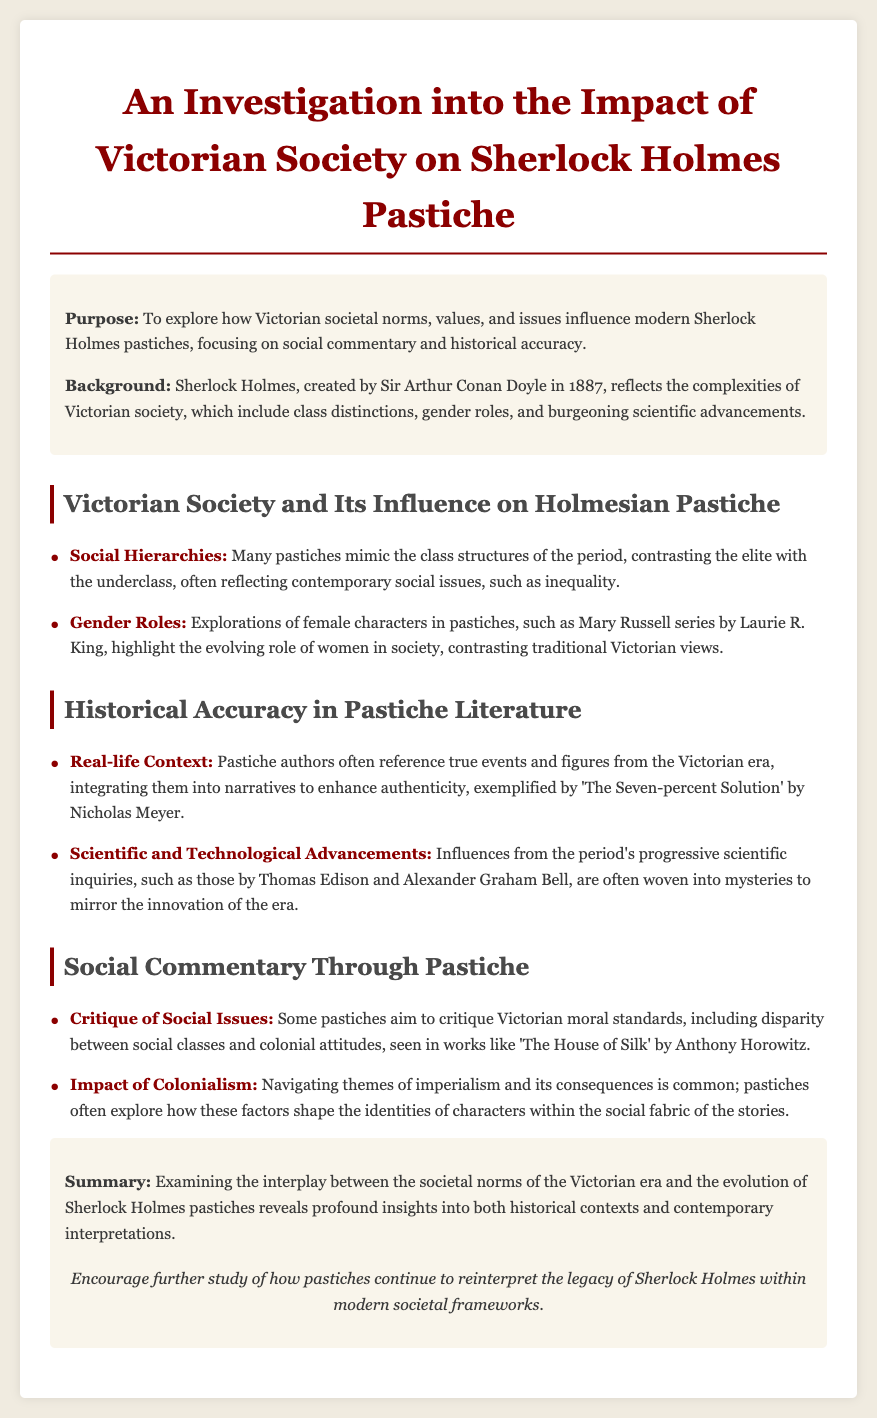What is the purpose of the investigation? The purpose is outlined in the introduction section, focusing on the exploration of Victorian societal norms and their influence on modern pastiches.
Answer: To explore how Victorian societal norms, values, and issues influence modern Sherlock Holmes pastiches What year was Sherlock Holmes created? The background section provides the information on the year of creation, which is noted as 1887.
Answer: 1887 Name one series that highlights evolving female roles. The document mentions the Mary Russell series by Laurie R. King as an example.
Answer: Mary Russell series Which author wrote 'The Seven-percent Solution'? The key point about real-life context identifies Nicholas Meyer as the author of this pastiche.
Answer: Nicholas Meyer What social issue do some pastiches critique? The document indicates that pastiches critique disparity between social classes as one of the Victorian moral standards.
Answer: Disparity between social classes How do pastiches enhance authenticity in their narratives? The key point about real-life context explains that pastiche authors integrate true events and figures to achieve this.
Answer: Integrating true events and figures What theme do pastiches often explore regarding colonialism? The document states that pastiches navigate themes of imperialism and its consequences within character identities.
Answer: Imperialism and its consequences Which author created 'The House of Silk'? The critique of social issues specifies that this work is by Anthony Horowitz.
Answer: Anthony Horowitz What does the conclusion encourage regarding pastiches? The conclusion suggests that there should be further study related to pastiches and their interpretations of Sherlock Holmes.
Answer: Further study of how pastiches continue to reinterpret the legacy of Sherlock Holmes 